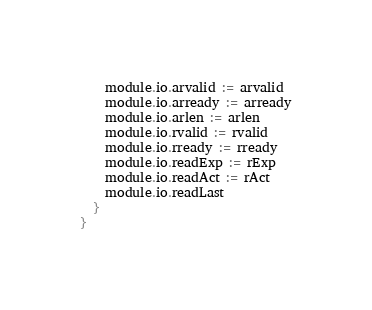<code> <loc_0><loc_0><loc_500><loc_500><_Scala_>    module.io.arvalid := arvalid
    module.io.arready := arready
    module.io.arlen := arlen
    module.io.rvalid := rvalid
    module.io.rready := rready
    module.io.readExp := rExp
    module.io.readAct := rAct
    module.io.readLast
  }
}
</code> 